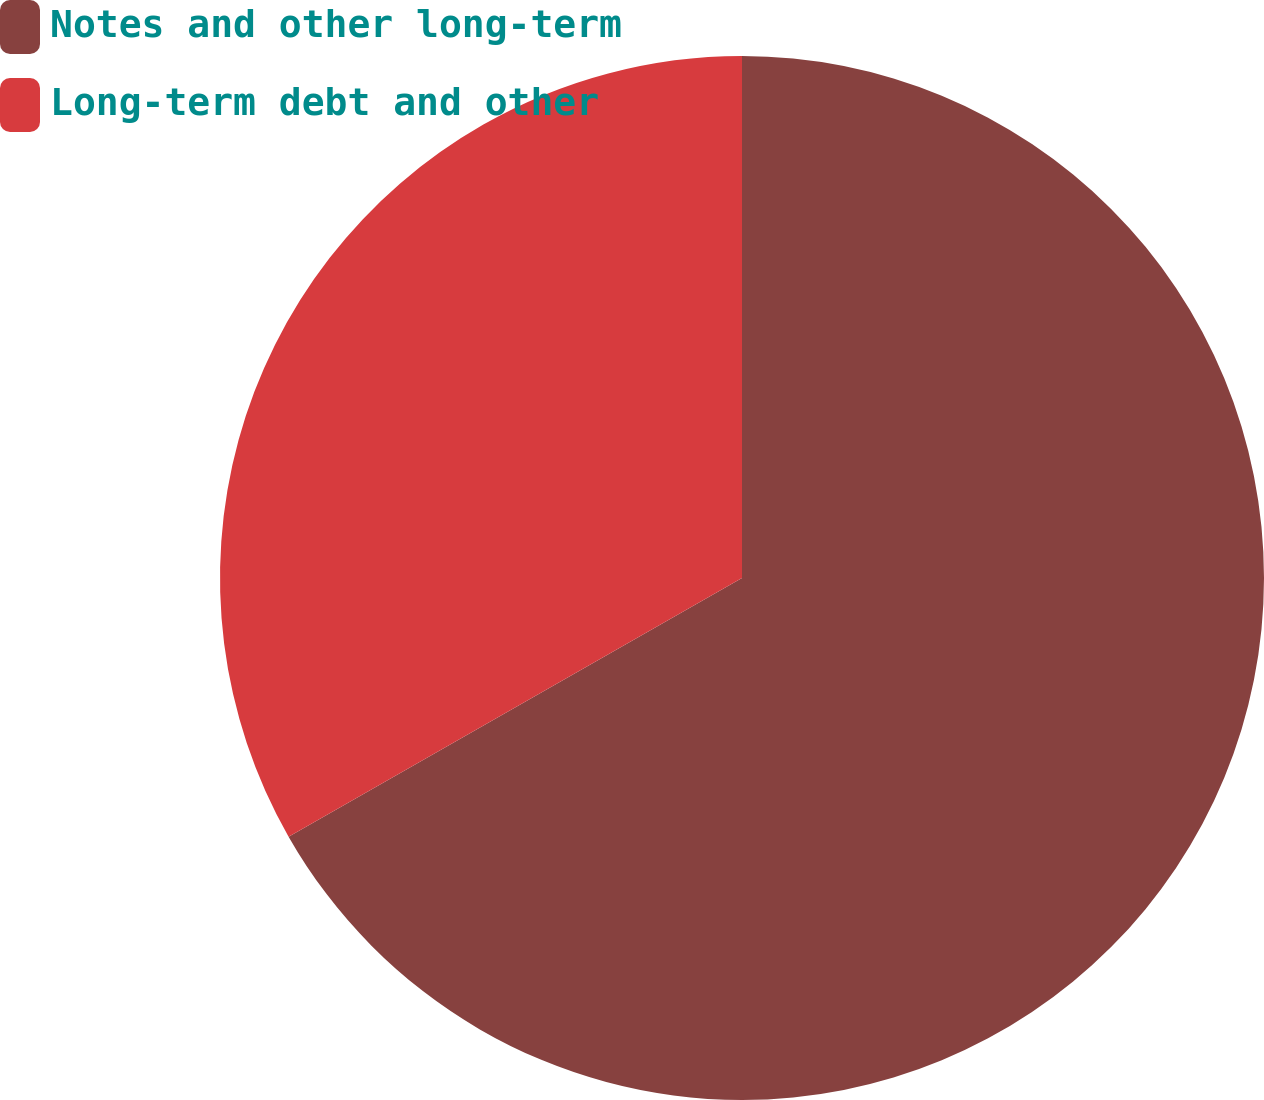Convert chart to OTSL. <chart><loc_0><loc_0><loc_500><loc_500><pie_chart><fcel>Notes and other long-term<fcel>Long-term debt and other<nl><fcel>66.75%<fcel>33.25%<nl></chart> 